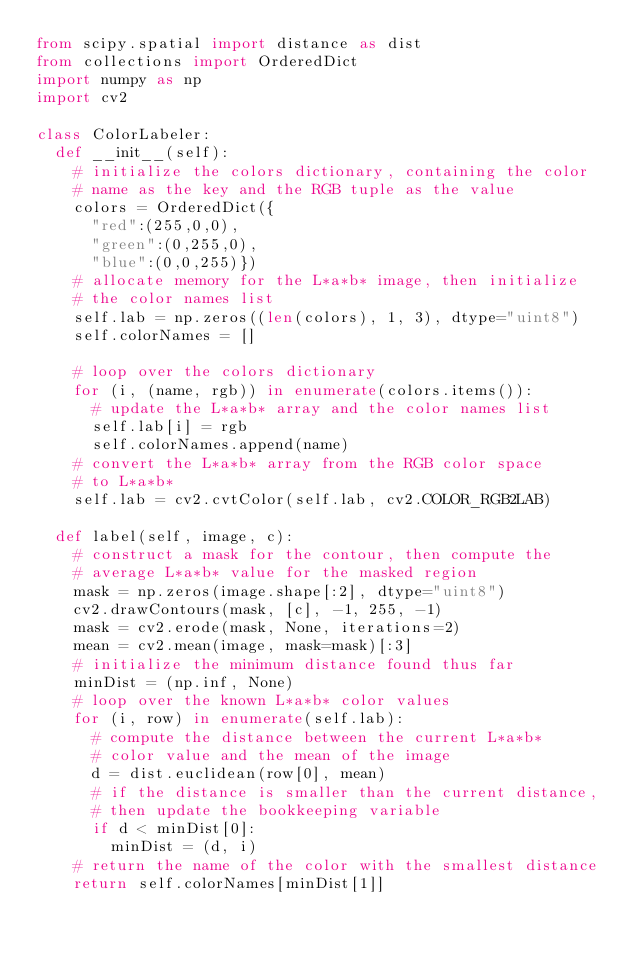<code> <loc_0><loc_0><loc_500><loc_500><_Python_>from scipy.spatial import distance as dist
from collections import OrderedDict
import numpy as np
import cv2

class ColorLabeler:
	def __init__(self):
		# initialize the colors dictionary, containing the color
		# name as the key and the RGB tuple as the value
		colors = OrderedDict({
			"red":(255,0,0),
			"green":(0,255,0),
			"blue":(0,0,255)})
		# allocate memory for the L*a*b* image, then initialize
		# the color names list
		self.lab = np.zeros((len(colors), 1, 3), dtype="uint8")
		self.colorNames = []
		
		# loop over the colors dictionary
		for (i, (name, rgb)) in enumerate(colors.items()):
			# update the L*a*b* array and the color names list
			self.lab[i] = rgb
			self.colorNames.append(name)
		# convert the L*a*b* array from the RGB color space
		# to L*a*b*
		self.lab = cv2.cvtColor(self.lab, cv2.COLOR_RGB2LAB)
		
	def label(self, image, c):
		# construct a mask for the contour, then compute the
		# average L*a*b* value for the masked region
		mask = np.zeros(image.shape[:2], dtype="uint8")
		cv2.drawContours(mask, [c], -1, 255, -1)
		mask = cv2.erode(mask, None, iterations=2)
		mean = cv2.mean(image, mask=mask)[:3]
		# initialize the minimum distance found thus far
		minDist = (np.inf, None)
		# loop over the known L*a*b* color values
		for (i, row) in enumerate(self.lab):
			# compute the distance between the current L*a*b*
			# color value and the mean of the image
			d = dist.euclidean(row[0], mean)
			# if the distance is smaller than the current distance,
			# then update the bookkeeping variable
			if d < minDist[0]:
				minDist = (d, i)
		# return the name of the color with the smallest distance
		return self.colorNames[minDist[1]]</code> 